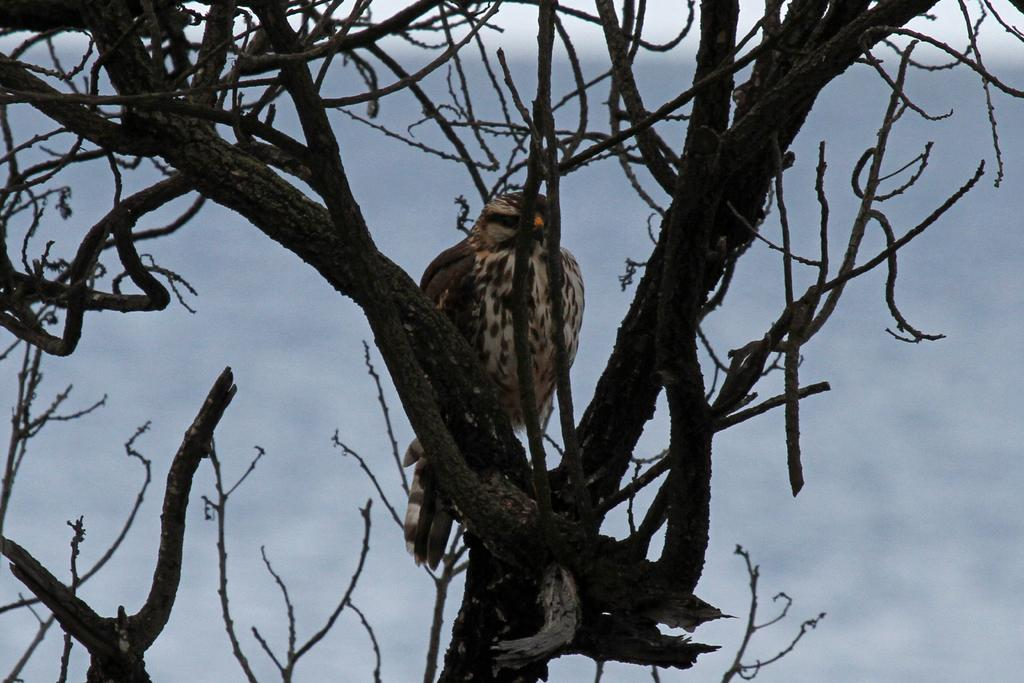What type of animal can be seen in the image? There is a bird in the image. Where is the bird located? The bird is sitting on a tree. Can you describe the bird's coloring? The bird has brown and white coloring. What is the condition of the tree next to the bird? There is a dried tree in the image. What is the color of the sky in the background? The sky in the background is white. How many vests can be seen on the bird in the image? There are no vests present on the bird in the image. What is the amount of girls visible in the image? There are no girls visible in the image; it features a bird sitting on a tree. 